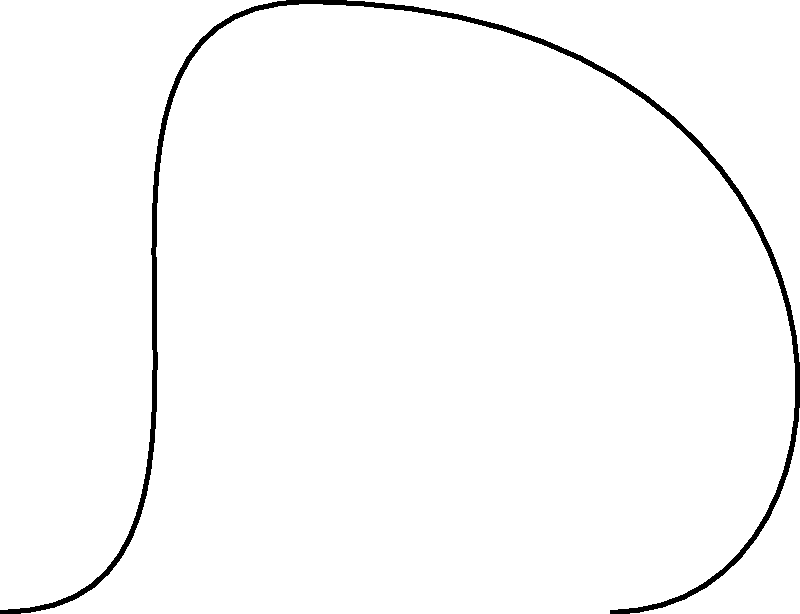When a church bell is rung, it experiences a complex stress distribution. Based on the diagram, which type of stress is predominantly experienced at the top of the bell, and how does this relate to the bell's shape and function? To understand the stress distribution in a church bell when rung, let's analyze the diagram step-by-step:

1. Bell shape: The bell has a characteristic curved profile, wider at the bottom and narrower at the top.

2. Stress indicators: The red arrows in the diagram represent the stress distribution. Their direction and placement are crucial for understanding the stress pattern.

3. Top of the bell: At the top, we see arrows pointing outward, indicating tensile stress.

4. Sides of the bell: Along the sides, the arrows are shorter and still pointing outward, showing less intense tensile stress.

5. Bottom of the bell: Near the bottom, there are no arrows, suggesting minimal stress in this area.

6. Stress type identification:
   - Outward-pointing arrows indicate tensile stress
   - Inward-pointing arrows (not present here) would indicate compressive stress

7. Relationship to shape and function:
   - The bell's shape, with a thinner top section, allows for greater flexibility and vibration.
   - This design facilitates the conversion of kinetic energy (from ringing) into sound energy.
   - The tensile stress at the top contributes to the bell's resonance and sound production.

8. Functional importance:
   - The stress distribution, particularly the tension at the top, is crucial for producing the bell's characteristic sound.
   - It allows the bell to vibrate efficiently, creating the desired tonal qualities.

In conclusion, the predominant stress at the top of the bell is tensile stress. This stress distribution is integral to the bell's acoustic properties and is a result of its carefully designed shape.
Answer: Tensile stress, crucial for sound production 